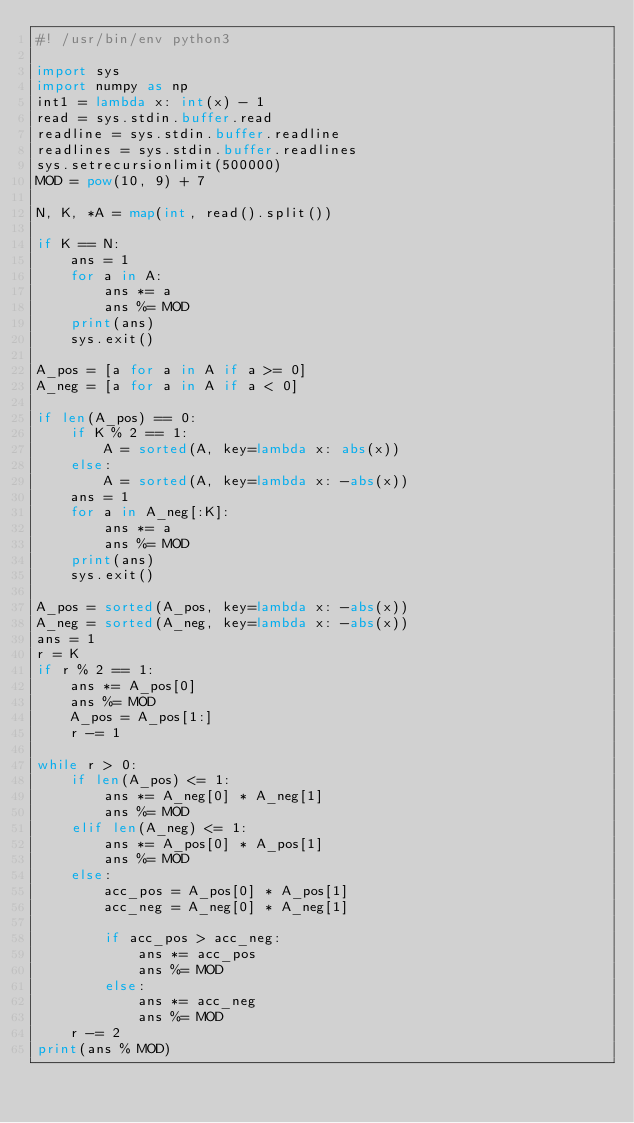Convert code to text. <code><loc_0><loc_0><loc_500><loc_500><_Python_>#! /usr/bin/env python3

import sys
import numpy as np
int1 = lambda x: int(x) - 1
read = sys.stdin.buffer.read
readline = sys.stdin.buffer.readline
readlines = sys.stdin.buffer.readlines
sys.setrecursionlimit(500000)
MOD = pow(10, 9) + 7

N, K, *A = map(int, read().split())

if K == N:
    ans = 1
    for a in A:
        ans *= a
        ans %= MOD
    print(ans)
    sys.exit()

A_pos = [a for a in A if a >= 0]
A_neg = [a for a in A if a < 0]

if len(A_pos) == 0:
    if K % 2 == 1:
        A = sorted(A, key=lambda x: abs(x))
    else:
        A = sorted(A, key=lambda x: -abs(x))
    ans = 1
    for a in A_neg[:K]:
        ans *= a
        ans %= MOD
    print(ans)
    sys.exit()

A_pos = sorted(A_pos, key=lambda x: -abs(x))
A_neg = sorted(A_neg, key=lambda x: -abs(x))
ans = 1
r = K
if r % 2 == 1:
    ans *= A_pos[0]
    ans %= MOD
    A_pos = A_pos[1:]
    r -= 1

while r > 0:
    if len(A_pos) <= 1:
        ans *= A_neg[0] * A_neg[1]
        ans %= MOD
    elif len(A_neg) <= 1:
        ans *= A_pos[0] * A_pos[1]
        ans %= MOD
    else:
        acc_pos = A_pos[0] * A_pos[1]
        acc_neg = A_neg[0] * A_neg[1]

        if acc_pos > acc_neg:
            ans *= acc_pos
            ans %= MOD
        else:
            ans *= acc_neg
            ans %= MOD
    r -= 2
print(ans % MOD)
</code> 